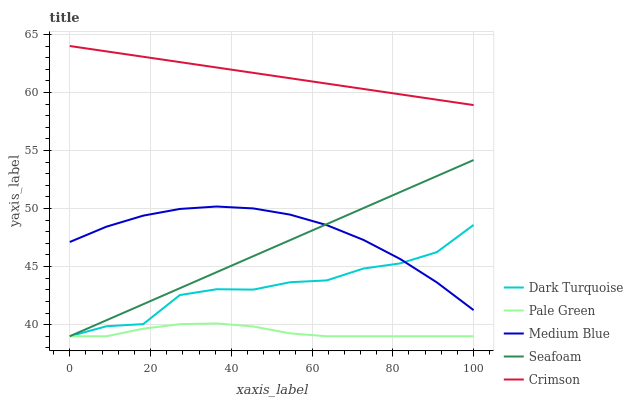Does Pale Green have the minimum area under the curve?
Answer yes or no. Yes. Does Crimson have the maximum area under the curve?
Answer yes or no. Yes. Does Dark Turquoise have the minimum area under the curve?
Answer yes or no. No. Does Dark Turquoise have the maximum area under the curve?
Answer yes or no. No. Is Crimson the smoothest?
Answer yes or no. Yes. Is Dark Turquoise the roughest?
Answer yes or no. Yes. Is Pale Green the smoothest?
Answer yes or no. No. Is Pale Green the roughest?
Answer yes or no. No. Does Medium Blue have the lowest value?
Answer yes or no. No. Does Crimson have the highest value?
Answer yes or no. Yes. Does Dark Turquoise have the highest value?
Answer yes or no. No. Is Seafoam less than Crimson?
Answer yes or no. Yes. Is Crimson greater than Dark Turquoise?
Answer yes or no. Yes. Does Seafoam intersect Crimson?
Answer yes or no. No. 